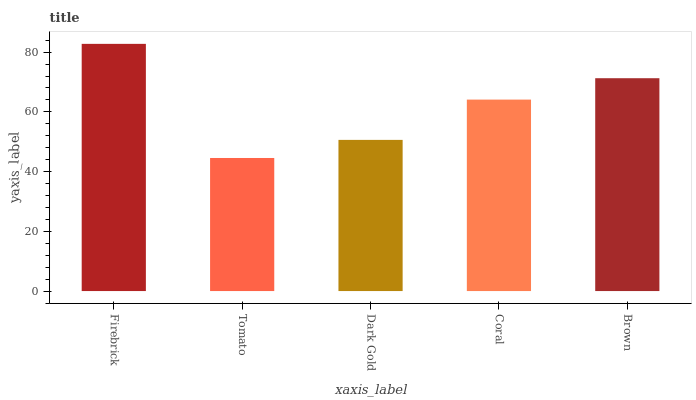Is Dark Gold the minimum?
Answer yes or no. No. Is Dark Gold the maximum?
Answer yes or no. No. Is Dark Gold greater than Tomato?
Answer yes or no. Yes. Is Tomato less than Dark Gold?
Answer yes or no. Yes. Is Tomato greater than Dark Gold?
Answer yes or no. No. Is Dark Gold less than Tomato?
Answer yes or no. No. Is Coral the high median?
Answer yes or no. Yes. Is Coral the low median?
Answer yes or no. Yes. Is Brown the high median?
Answer yes or no. No. Is Brown the low median?
Answer yes or no. No. 